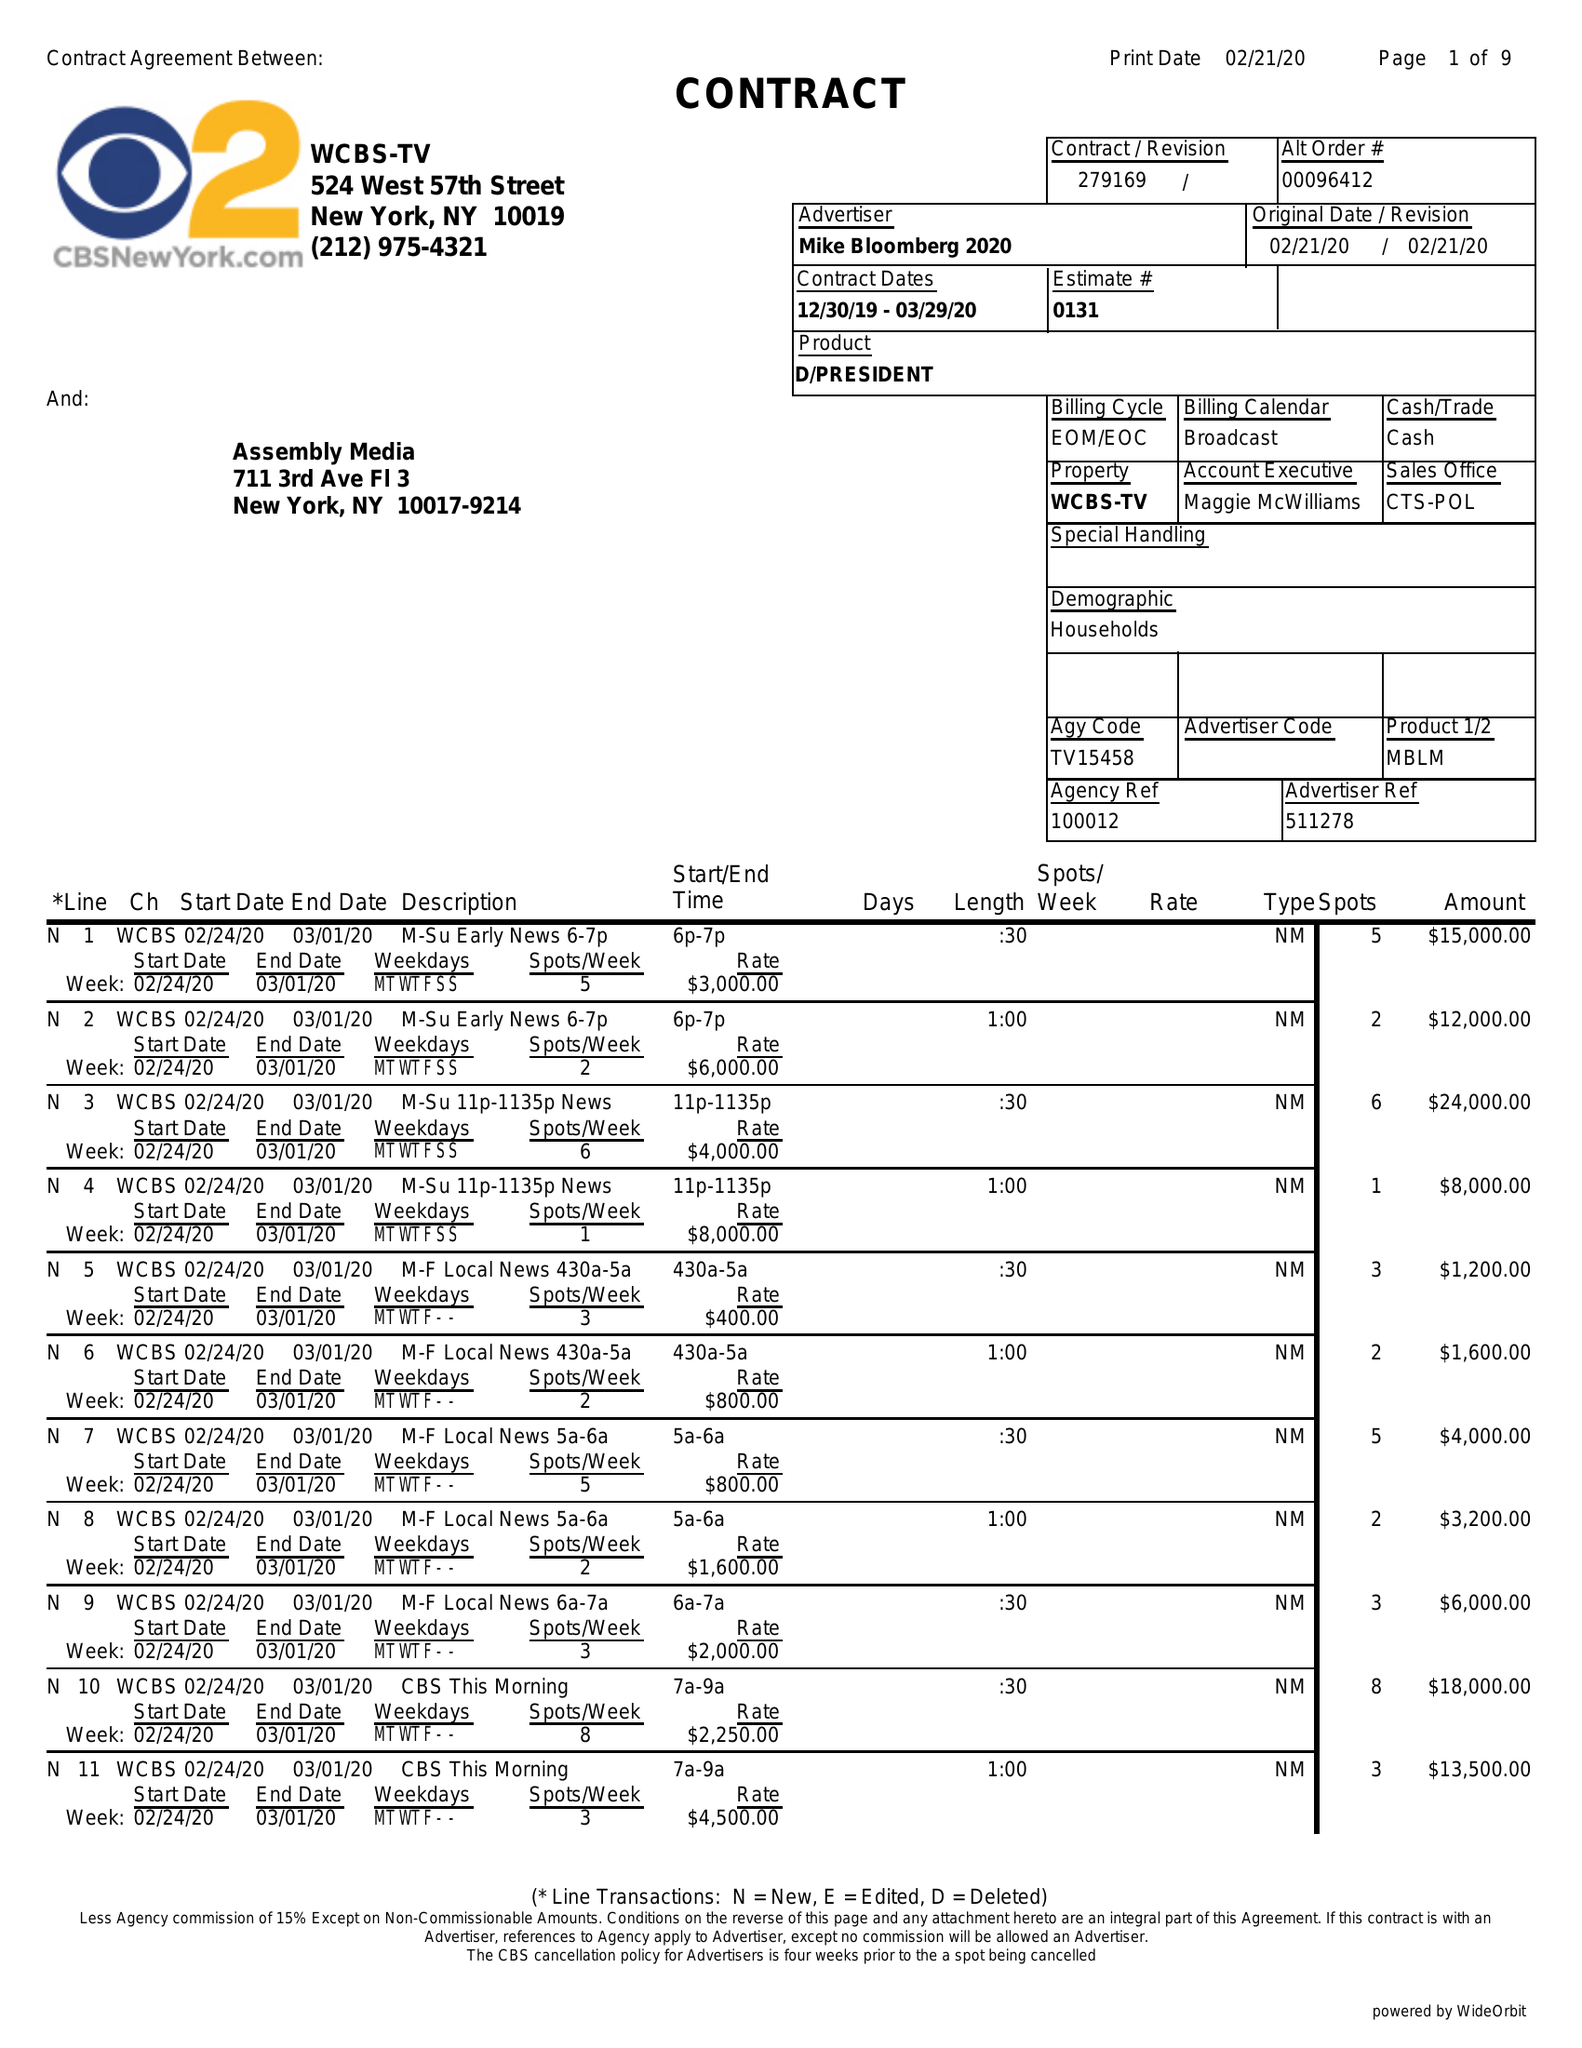What is the value for the flight_from?
Answer the question using a single word or phrase. 12/30/19 